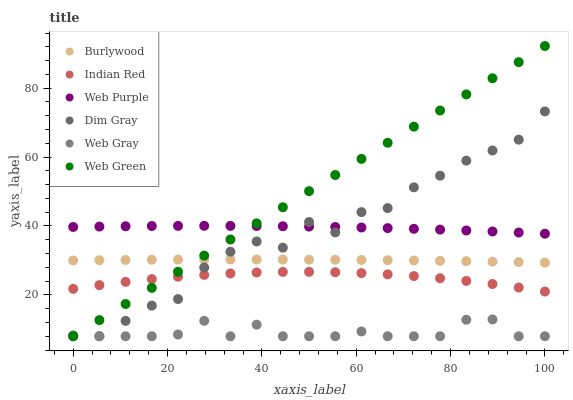Does Web Gray have the minimum area under the curve?
Answer yes or no. Yes. Does Web Green have the maximum area under the curve?
Answer yes or no. Yes. Does Burlywood have the minimum area under the curve?
Answer yes or no. No. Does Burlywood have the maximum area under the curve?
Answer yes or no. No. Is Web Green the smoothest?
Answer yes or no. Yes. Is Dim Gray the roughest?
Answer yes or no. Yes. Is Burlywood the smoothest?
Answer yes or no. No. Is Burlywood the roughest?
Answer yes or no. No. Does Dim Gray have the lowest value?
Answer yes or no. Yes. Does Burlywood have the lowest value?
Answer yes or no. No. Does Web Green have the highest value?
Answer yes or no. Yes. Does Burlywood have the highest value?
Answer yes or no. No. Is Web Gray less than Web Purple?
Answer yes or no. Yes. Is Web Purple greater than Web Gray?
Answer yes or no. Yes. Does Web Green intersect Web Gray?
Answer yes or no. Yes. Is Web Green less than Web Gray?
Answer yes or no. No. Is Web Green greater than Web Gray?
Answer yes or no. No. Does Web Gray intersect Web Purple?
Answer yes or no. No. 